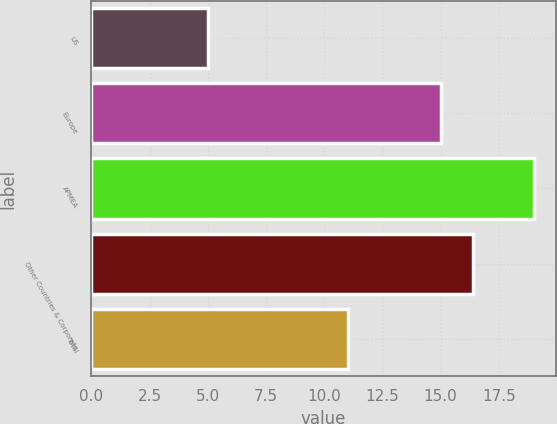<chart> <loc_0><loc_0><loc_500><loc_500><bar_chart><fcel>US<fcel>Europe<fcel>APMEA<fcel>Other Countries & Corporate<fcel>Total<nl><fcel>5<fcel>15<fcel>19<fcel>16.4<fcel>11<nl></chart> 